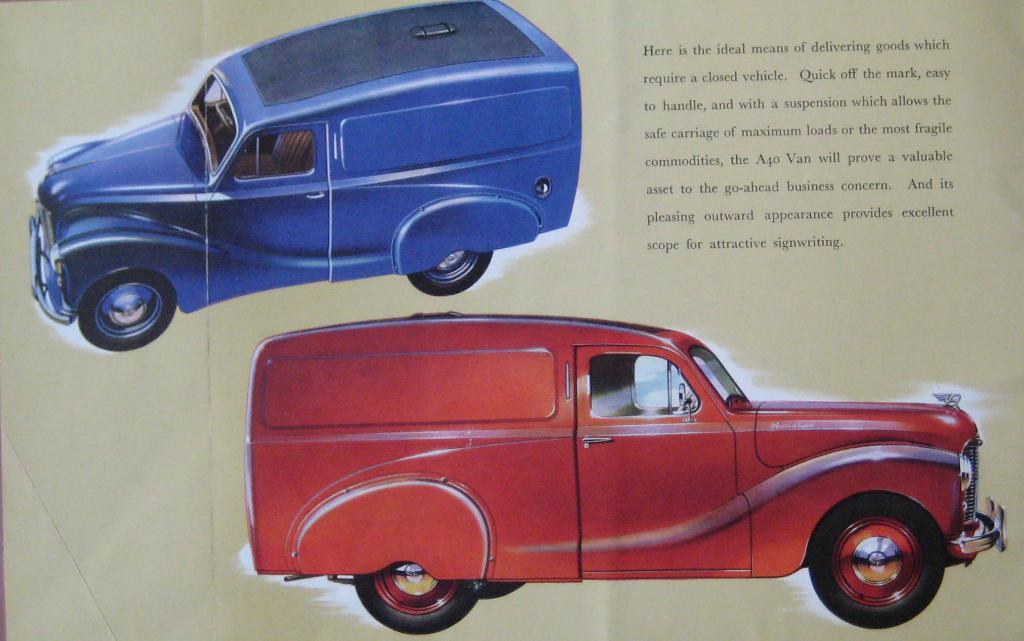What is depicted on the paper in the image? The paper contains pictures of vans. Can you describe the colors of the vans in the image? One van is red in color, and one van is blue in color. Are there any words or letters on the paper? Yes, there are letters written on the paper. Can you tell me how many flowers are depicted on the paper? There are no flowers depicted on the paper; it features pictures of vans. What type of vein is visible on the red van in the image? There are no veins visible on the red van in the image, as it is a picture of a vehicle and not a living organism. 